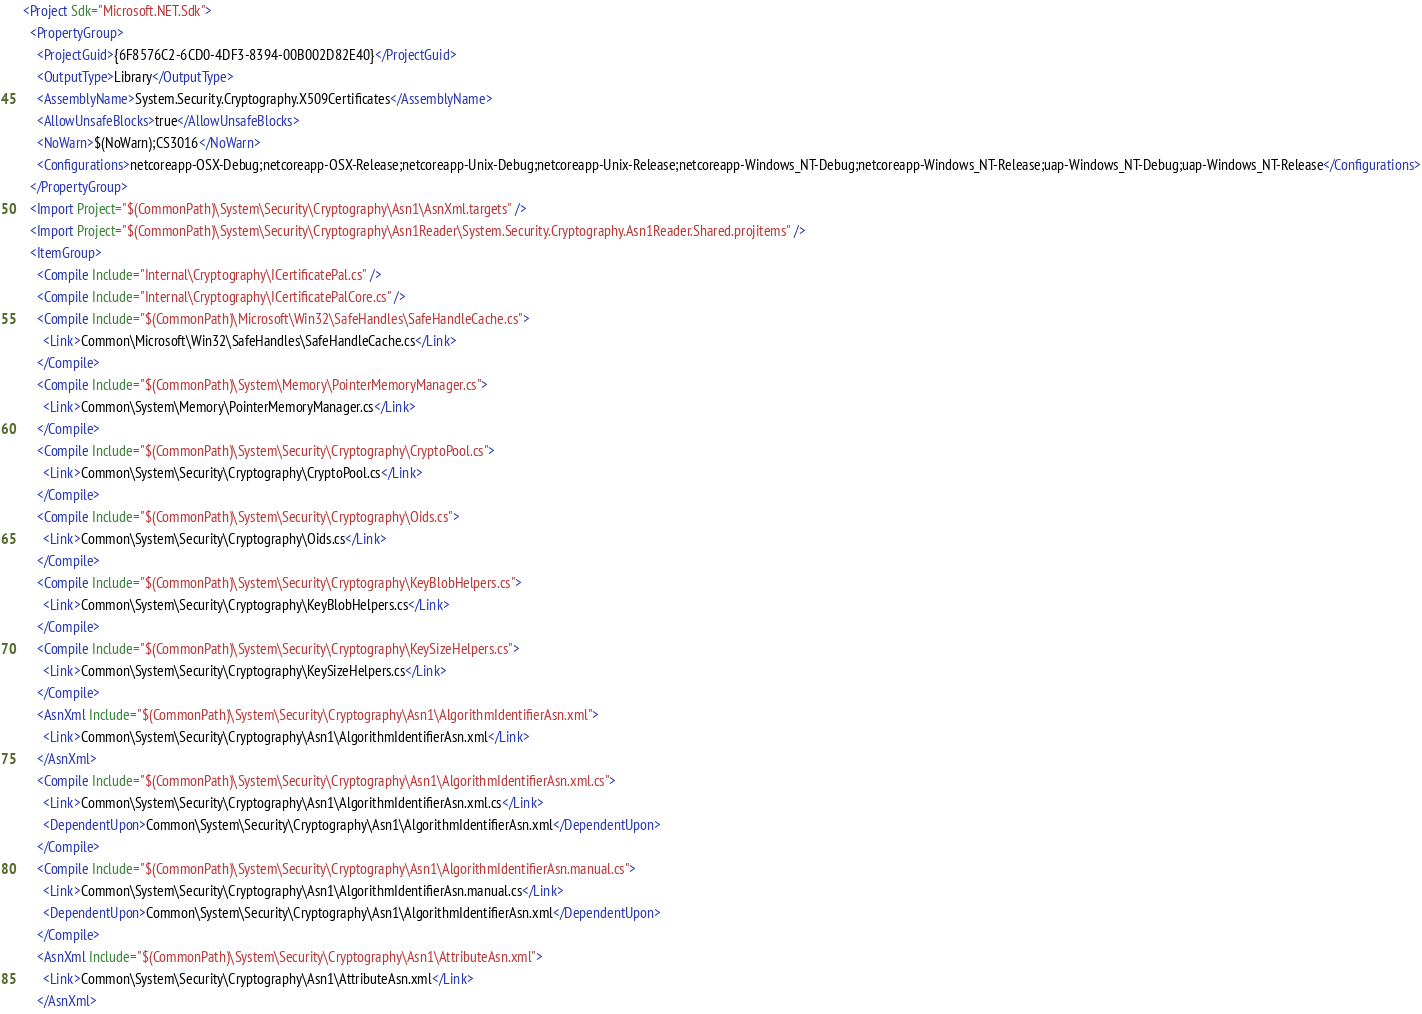<code> <loc_0><loc_0><loc_500><loc_500><_XML_><Project Sdk="Microsoft.NET.Sdk">
  <PropertyGroup>
    <ProjectGuid>{6F8576C2-6CD0-4DF3-8394-00B002D82E40}</ProjectGuid>
    <OutputType>Library</OutputType>
    <AssemblyName>System.Security.Cryptography.X509Certificates</AssemblyName>
    <AllowUnsafeBlocks>true</AllowUnsafeBlocks>
    <NoWarn>$(NoWarn);CS3016</NoWarn>
    <Configurations>netcoreapp-OSX-Debug;netcoreapp-OSX-Release;netcoreapp-Unix-Debug;netcoreapp-Unix-Release;netcoreapp-Windows_NT-Debug;netcoreapp-Windows_NT-Release;uap-Windows_NT-Debug;uap-Windows_NT-Release</Configurations>
  </PropertyGroup>
  <Import Project="$(CommonPath)\System\Security\Cryptography\Asn1\AsnXml.targets" />
  <Import Project="$(CommonPath)\System\Security\Cryptography\Asn1Reader\System.Security.Cryptography.Asn1Reader.Shared.projitems" />
  <ItemGroup>
    <Compile Include="Internal\Cryptography\ICertificatePal.cs" />
    <Compile Include="Internal\Cryptography\ICertificatePalCore.cs" />
    <Compile Include="$(CommonPath)\Microsoft\Win32\SafeHandles\SafeHandleCache.cs">
      <Link>Common\Microsoft\Win32\SafeHandles\SafeHandleCache.cs</Link>
    </Compile>
    <Compile Include="$(CommonPath)\System\Memory\PointerMemoryManager.cs">
      <Link>Common\System\Memory\PointerMemoryManager.cs</Link>
    </Compile>
    <Compile Include="$(CommonPath)\System\Security\Cryptography\CryptoPool.cs">
      <Link>Common\System\Security\Cryptography\CryptoPool.cs</Link>
    </Compile>
    <Compile Include="$(CommonPath)\System\Security\Cryptography\Oids.cs">
      <Link>Common\System\Security\Cryptography\Oids.cs</Link>
    </Compile>
    <Compile Include="$(CommonPath)\System\Security\Cryptography\KeyBlobHelpers.cs">
      <Link>Common\System\Security\Cryptography\KeyBlobHelpers.cs</Link>
    </Compile>
    <Compile Include="$(CommonPath)\System\Security\Cryptography\KeySizeHelpers.cs">
      <Link>Common\System\Security\Cryptography\KeySizeHelpers.cs</Link>
    </Compile>
    <AsnXml Include="$(CommonPath)\System\Security\Cryptography\Asn1\AlgorithmIdentifierAsn.xml">
      <Link>Common\System\Security\Cryptography\Asn1\AlgorithmIdentifierAsn.xml</Link>
    </AsnXml>
    <Compile Include="$(CommonPath)\System\Security\Cryptography\Asn1\AlgorithmIdentifierAsn.xml.cs">
      <Link>Common\System\Security\Cryptography\Asn1\AlgorithmIdentifierAsn.xml.cs</Link>
      <DependentUpon>Common\System\Security\Cryptography\Asn1\AlgorithmIdentifierAsn.xml</DependentUpon>
    </Compile>
    <Compile Include="$(CommonPath)\System\Security\Cryptography\Asn1\AlgorithmIdentifierAsn.manual.cs">
      <Link>Common\System\Security\Cryptography\Asn1\AlgorithmIdentifierAsn.manual.cs</Link>
      <DependentUpon>Common\System\Security\Cryptography\Asn1\AlgorithmIdentifierAsn.xml</DependentUpon>
    </Compile>
    <AsnXml Include="$(CommonPath)\System\Security\Cryptography\Asn1\AttributeAsn.xml">
      <Link>Common\System\Security\Cryptography\Asn1\AttributeAsn.xml</Link>
    </AsnXml></code> 